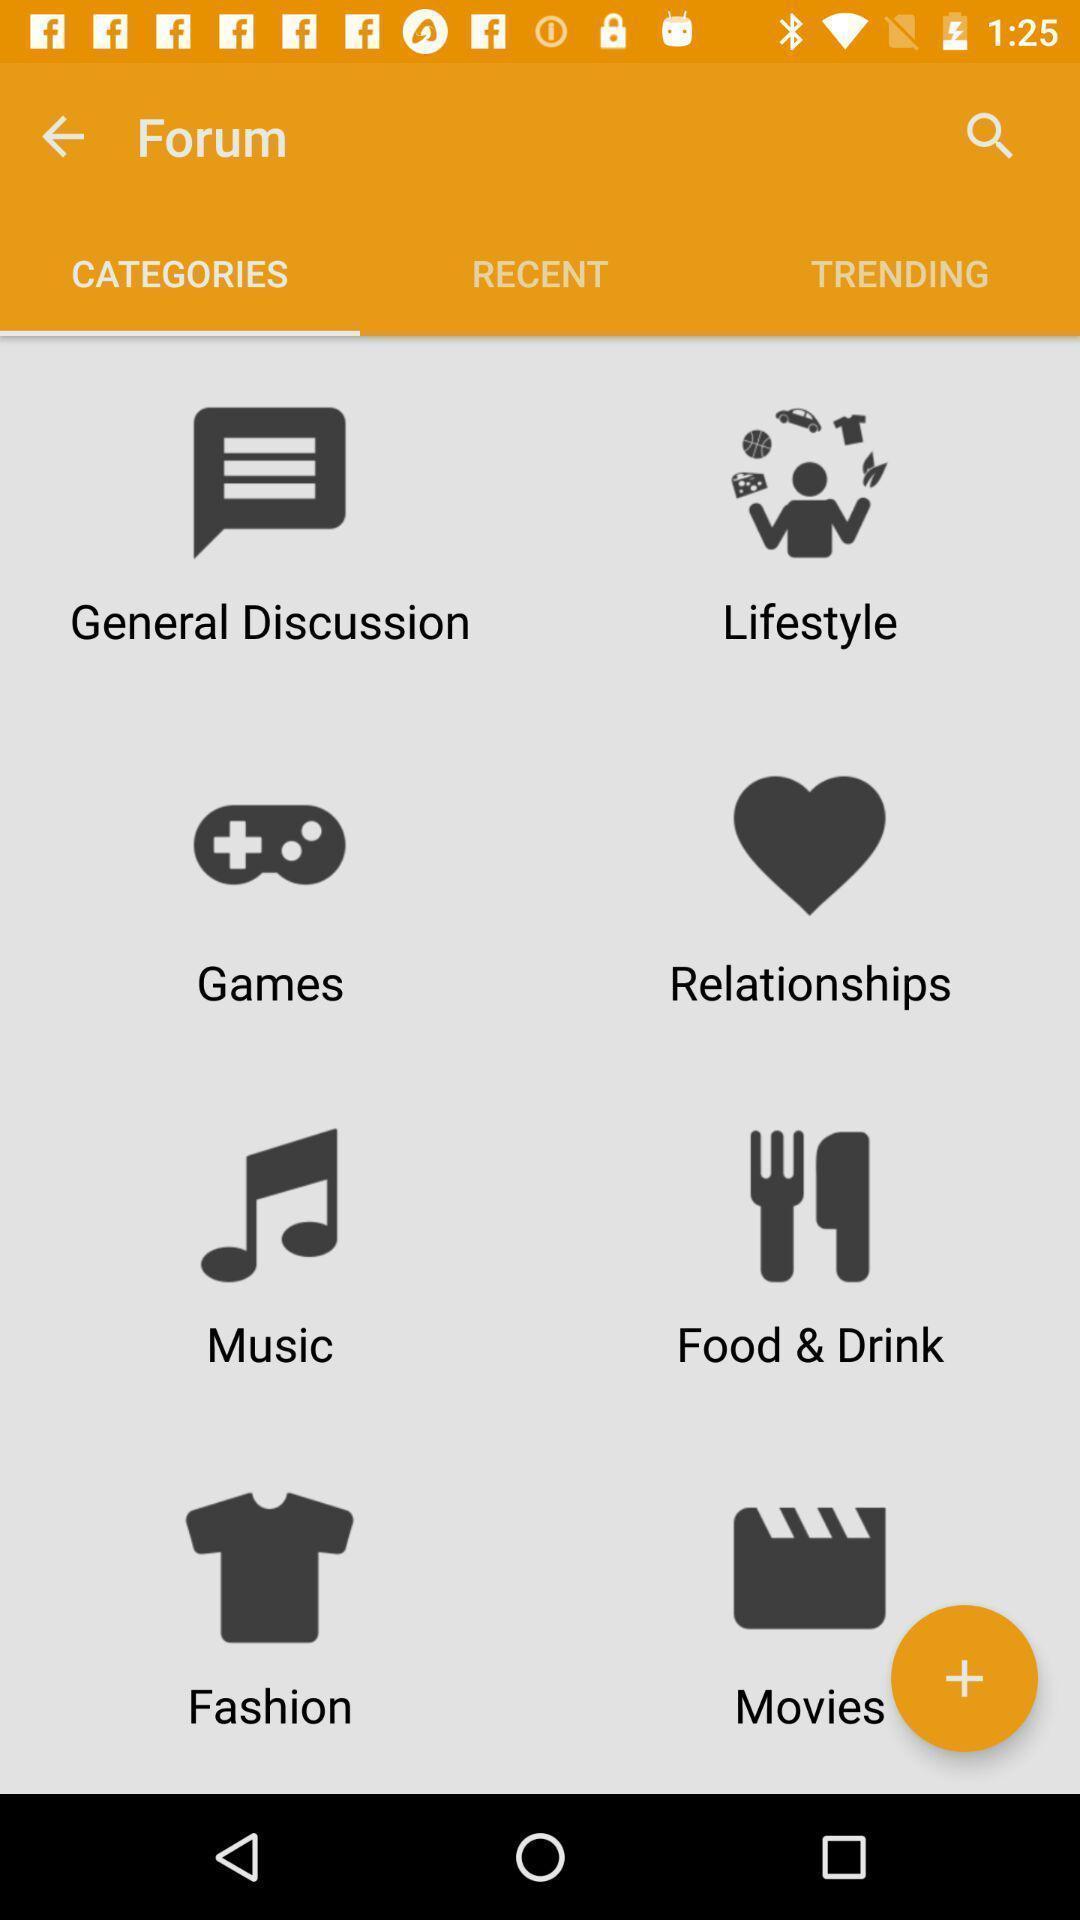Describe the visual elements of this screenshot. Page displays different categories in app. 